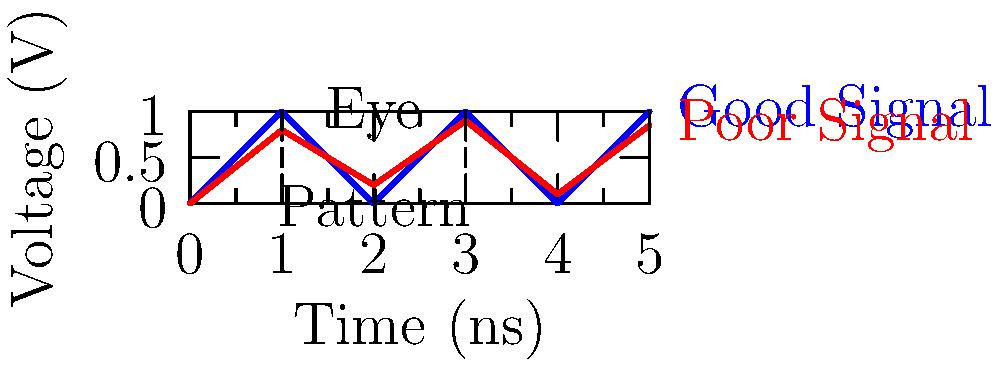As a software architect implementing automated code analysis for PCB design tools, you're reviewing a feature for signal integrity analysis. The image shows two digital signals: a good signal (blue) and a poor signal (red). What key parameter of signal integrity is best represented by the difference between these two signals, and how might this impact high-speed data transfer in PCB layouts? To answer this question, let's analyze the signals step-by-step:

1. Signal Characteristics:
   - The blue line represents an ideal digital signal with sharp transitions between 0 and 1.
   - The red line shows a degraded signal with slower rise/fall times and reduced amplitude.

2. Key Parameter Identification:
   - The main difference between the signals is the sharpness of transitions and the stability of high/low states.
   - This difference primarily represents the "Eye Pattern" of the signal.

3. Eye Pattern Analysis:
   - An eye pattern is formed by overlapping time intervals of a signal.
   - The "open" area of the eye represents the window where the signal can be reliably sampled.

4. Impact on High-Speed Data Transfer:
   - A wider eye opening (blue signal) allows for:
     a) More reliable data sampling
     b) Higher data rates
     c) Lower bit error rates (BER)
   - A smaller eye opening (red signal) results in:
     a) Reduced timing margins
     b) Increased jitter
     c) Higher likelihood of data errors

5. PCB Layout Considerations:
   - To maintain good signal integrity, PCB designers must consider:
     a) Proper impedance matching
     b) Minimizing crosstalk
     c) Controlling trace lengths and routing

6. Automated Analysis Tool Implications:
   - An automated tool should be able to:
     a) Simulate and predict eye patterns
     b) Identify potential signal integrity issues
     c) Suggest layout improvements to maintain signal quality

The key parameter represented here is the "Eye Pattern" quality, which directly impacts the reliability and maximum achievable data rate in high-speed PCB designs.
Answer: Eye Pattern quality 